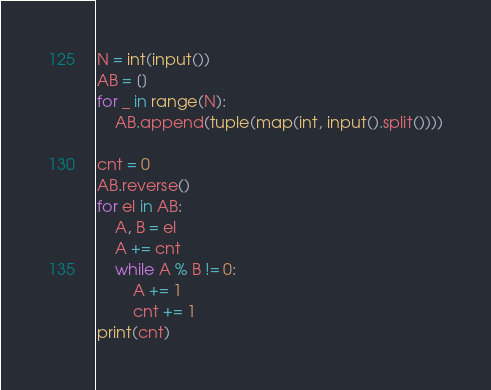Convert code to text. <code><loc_0><loc_0><loc_500><loc_500><_Python_>N = int(input())
AB = []
for _ in range(N):
    AB.append(tuple(map(int, input().split())))

cnt = 0
AB.reverse()
for el in AB:
    A, B = el
    A += cnt
    while A % B != 0:
        A += 1
        cnt += 1
print(cnt)</code> 